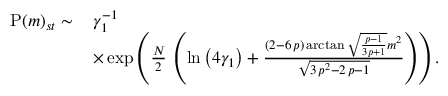<formula> <loc_0><loc_0><loc_500><loc_500>\begin{array} { r l } { P ( m ) _ { s t } \sim \, } & { \gamma _ { 1 } ^ { - 1 } } \\ & { \times \exp \left ( \frac { N } { 2 } \, \left ( \ln \left ( 4 \gamma _ { 1 } \right ) + \frac { \left ( 2 - 6 \, p \right ) \arctan \sqrt { \frac { p - 1 } { 3 p + 1 } } m ^ { 2 } } { \sqrt { 3 \, p ^ { 2 } - 2 \, p - 1 } } \right ) \right ) . } \end{array}</formula> 